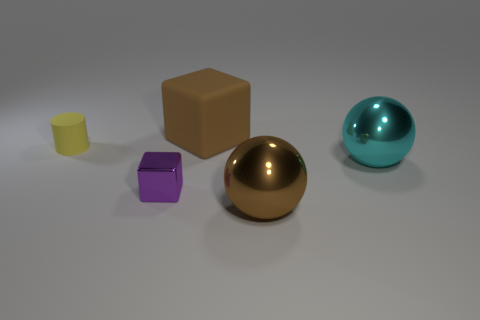Subtract 1 blocks. How many blocks are left? 1 Add 1 brown blocks. How many objects exist? 6 Subtract all brown cubes. How many cubes are left? 1 Subtract all balls. How many objects are left? 3 Subtract all blue cylinders. How many brown spheres are left? 1 Add 3 tiny cyan shiny cylinders. How many tiny cyan shiny cylinders exist? 3 Subtract 0 yellow spheres. How many objects are left? 5 Subtract all purple blocks. Subtract all red cylinders. How many blocks are left? 1 Subtract all small purple cylinders. Subtract all big metal objects. How many objects are left? 3 Add 5 big brown rubber objects. How many big brown rubber objects are left? 6 